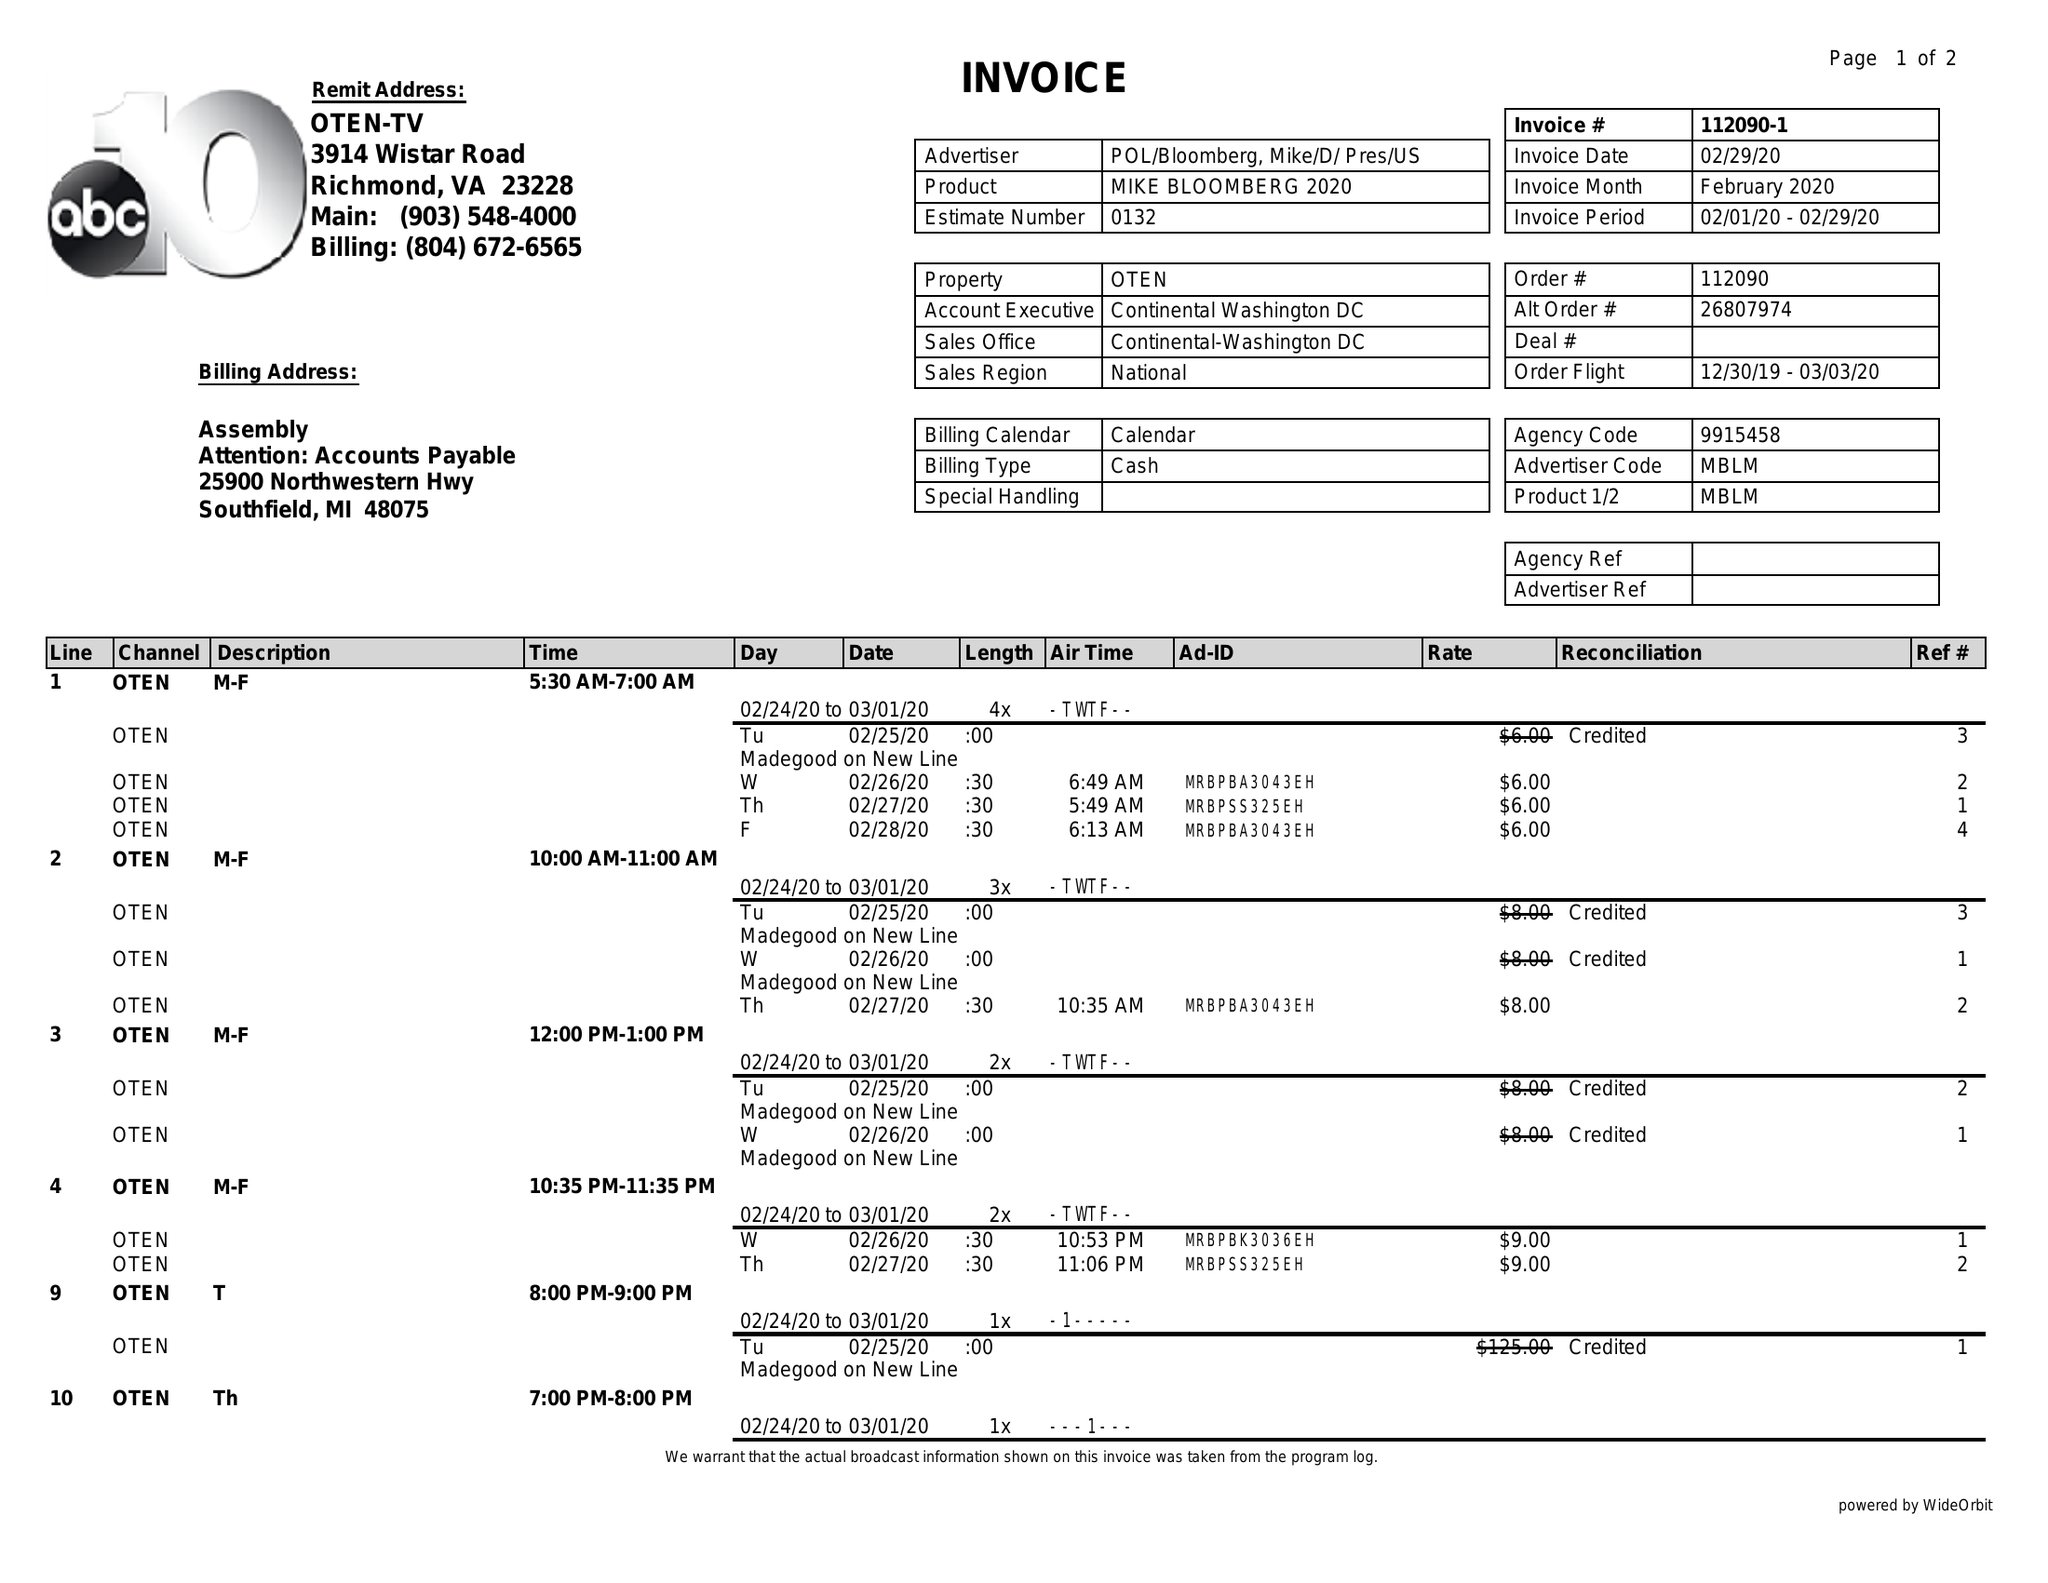What is the value for the advertiser?
Answer the question using a single word or phrase. POL/BLOOMBERG,MIKE/D/PRES/US 